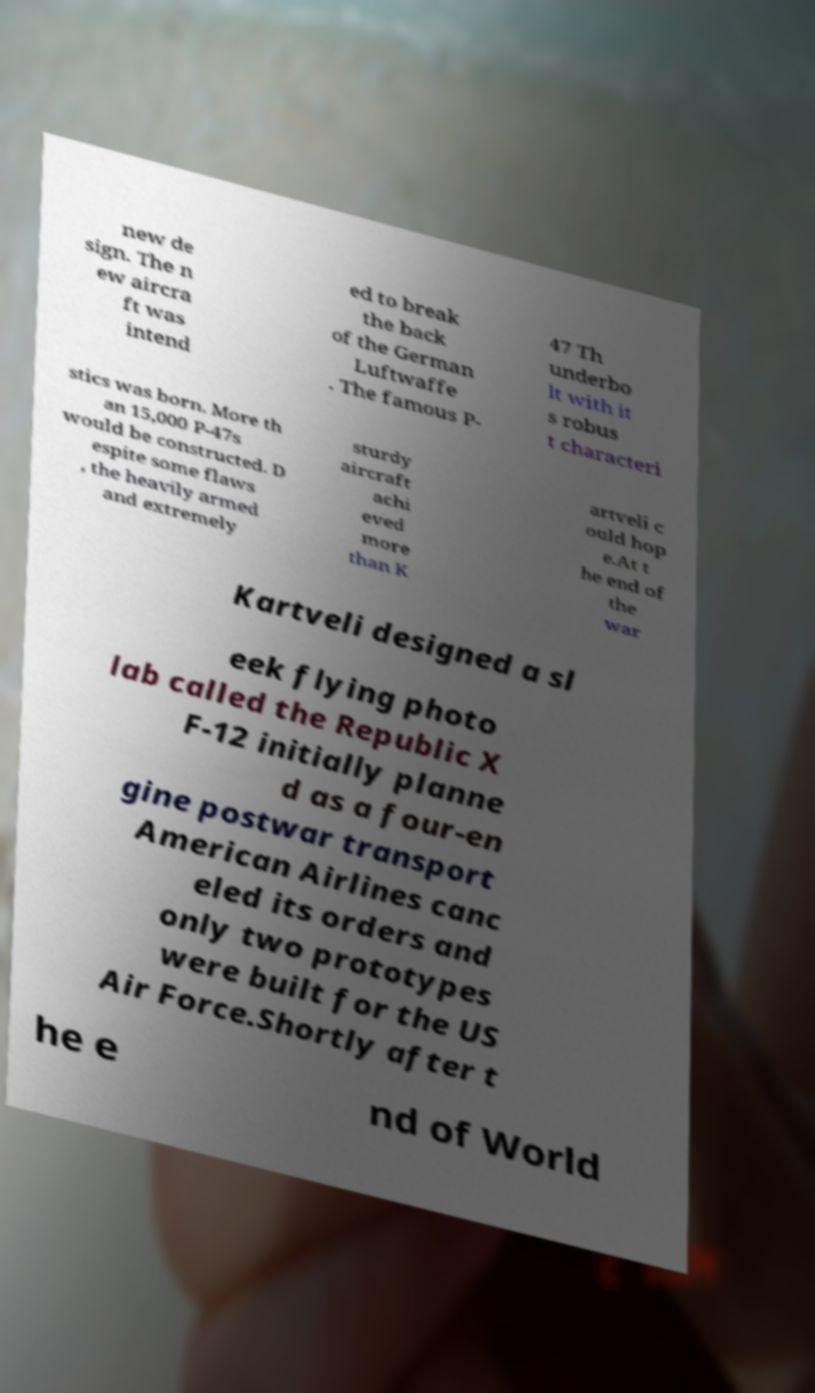Can you accurately transcribe the text from the provided image for me? new de sign. The n ew aircra ft was intend ed to break the back of the German Luftwaffe . The famous P- 47 Th underbo lt with it s robus t characteri stics was born. More th an 15,000 P-47s would be constructed. D espite some flaws , the heavily armed and extremely sturdy aircraft achi eved more than K artveli c ould hop e.At t he end of the war Kartveli designed a sl eek flying photo lab called the Republic X F-12 initially planne d as a four-en gine postwar transport American Airlines canc eled its orders and only two prototypes were built for the US Air Force.Shortly after t he e nd of World 